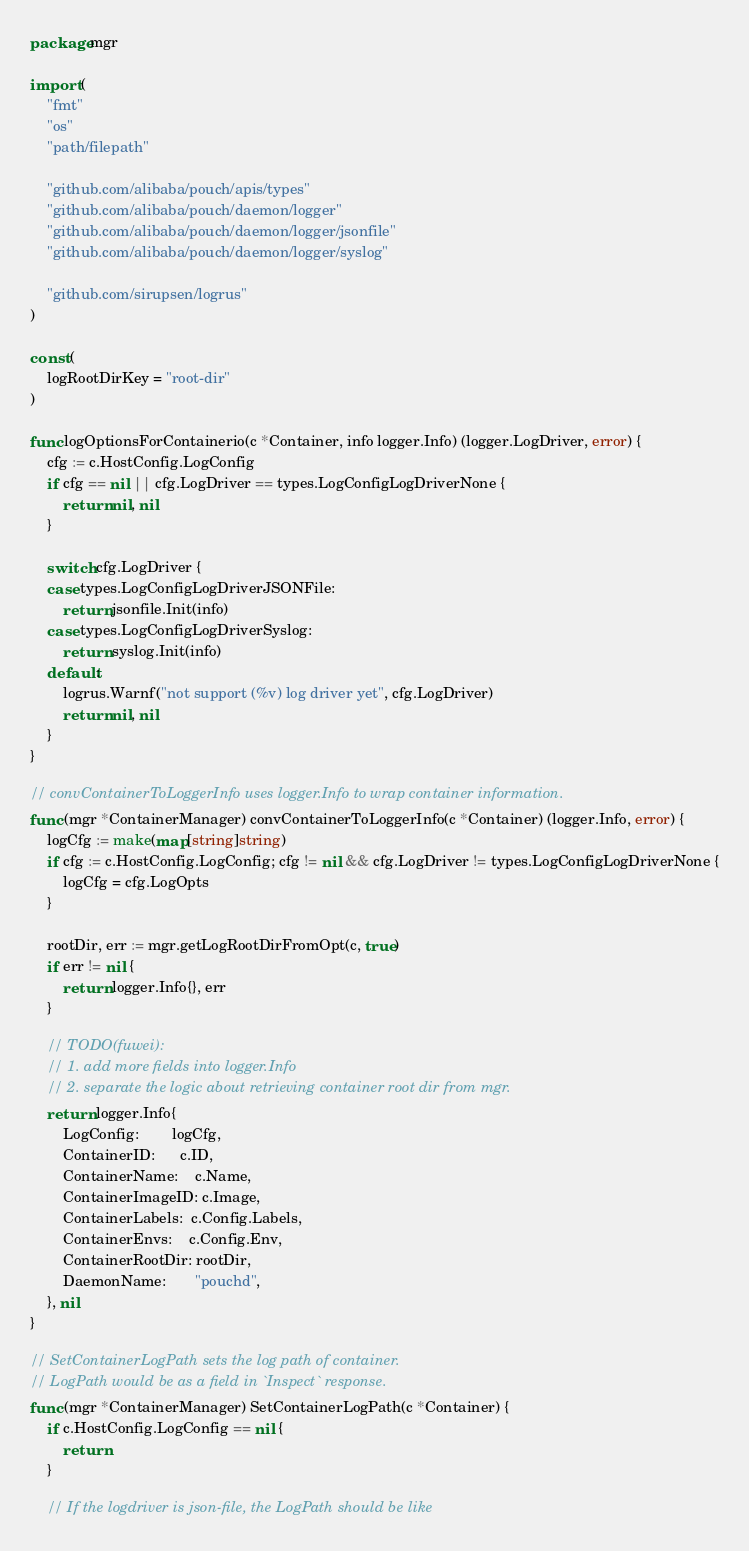Convert code to text. <code><loc_0><loc_0><loc_500><loc_500><_Go_>package mgr

import (
	"fmt"
	"os"
	"path/filepath"

	"github.com/alibaba/pouch/apis/types"
	"github.com/alibaba/pouch/daemon/logger"
	"github.com/alibaba/pouch/daemon/logger/jsonfile"
	"github.com/alibaba/pouch/daemon/logger/syslog"

	"github.com/sirupsen/logrus"
)

const (
	logRootDirKey = "root-dir"
)

func logOptionsForContainerio(c *Container, info logger.Info) (logger.LogDriver, error) {
	cfg := c.HostConfig.LogConfig
	if cfg == nil || cfg.LogDriver == types.LogConfigLogDriverNone {
		return nil, nil
	}

	switch cfg.LogDriver {
	case types.LogConfigLogDriverJSONFile:
		return jsonfile.Init(info)
	case types.LogConfigLogDriverSyslog:
		return syslog.Init(info)
	default:
		logrus.Warnf("not support (%v) log driver yet", cfg.LogDriver)
		return nil, nil
	}
}

// convContainerToLoggerInfo uses logger.Info to wrap container information.
func (mgr *ContainerManager) convContainerToLoggerInfo(c *Container) (logger.Info, error) {
	logCfg := make(map[string]string)
	if cfg := c.HostConfig.LogConfig; cfg != nil && cfg.LogDriver != types.LogConfigLogDriverNone {
		logCfg = cfg.LogOpts
	}

	rootDir, err := mgr.getLogRootDirFromOpt(c, true)
	if err != nil {
		return logger.Info{}, err
	}

	// TODO(fuwei):
	// 1. add more fields into logger.Info
	// 2. separate the logic about retrieving container root dir from mgr.
	return logger.Info{
		LogConfig:        logCfg,
		ContainerID:      c.ID,
		ContainerName:    c.Name,
		ContainerImageID: c.Image,
		ContainerLabels:  c.Config.Labels,
		ContainerEnvs:    c.Config.Env,
		ContainerRootDir: rootDir,
		DaemonName:       "pouchd",
	}, nil
}

// SetContainerLogPath sets the log path of container.
// LogPath would be as a field in `Inspect` response.
func (mgr *ContainerManager) SetContainerLogPath(c *Container) {
	if c.HostConfig.LogConfig == nil {
		return
	}

	// If the logdriver is json-file, the LogPath should be like</code> 